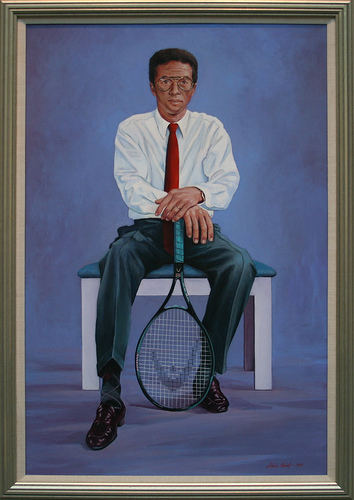Create a short story where the man in the image is a retired tennis coach now advising young players. Once a star on the tennis court, the man retired from professional play but never strayed far from the sport. Now, as a respected coach, he spends his days at the local tennis academy, imparting wisdom and technique to the new generation. His red tie has become a symbol of his legacy, worn in honor of his greatest victory. Young players look up to him, not just for his instruction, but for his life stories that blend technical advice with valuable life lessons. His presence on the court, the blue background of the academy walls echoing his past, inspires them to strive for greatness. 